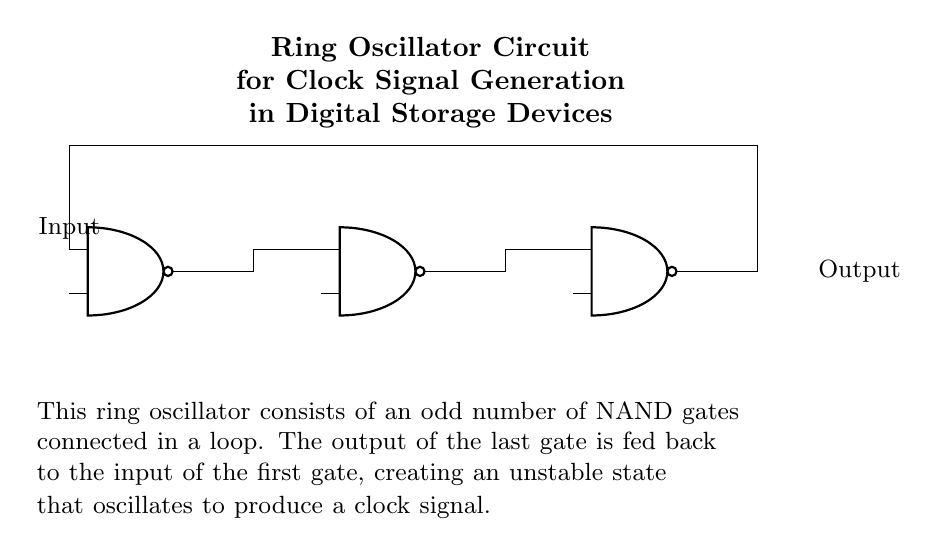What is the type of gates used in this oscillator? The circuit shows an arrangement of NAND gates, which are indicated by the symbol of the gates in the diagram. Each gate in the oscillator is labeled as a NAND gate.
Answer: NAND gates How many NAND gates are there in the circuit? By counting the diagram, there are three NAND gates connected in a loop to form the ring oscillator. The visual representation clearly shows three distinct NAND gate symbols.
Answer: Three What is the role of feedback in this ring oscillator? The feedback is essential for oscillation, as it connects the output of the last NAND gate back to the first gate's input, creating an unstable state that drives the oscillation. This cyclical feedback loop is foundational for the operation of the oscillator as it maintains continuous signal generation.
Answer: Oscillation What is generated by this ring oscillator circuit? The primary output of a ring oscillator circuit is a clock signal, which is utilized in various digital storage devices for timing purposes. This is indicated by the description in the diagram stating its purpose.
Answer: Clock signal Why is an odd number of gates used in the oscillator? An odd number of gates is necessary to ensure that the feedback leads to unstable operation; if an even number were used, the function would lead to a stable steady state where the output would not oscillate. This principle is critical for understanding the behavior of ring oscillators.
Answer: Stability 